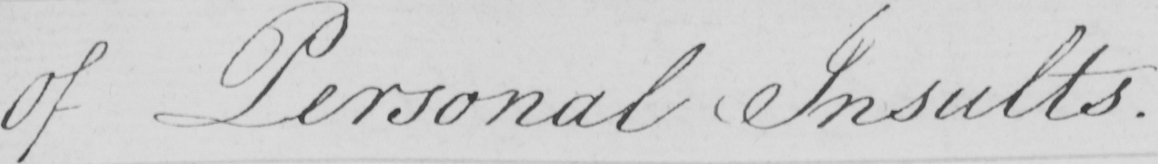Please provide the text content of this handwritten line. Of Personal Insults . 